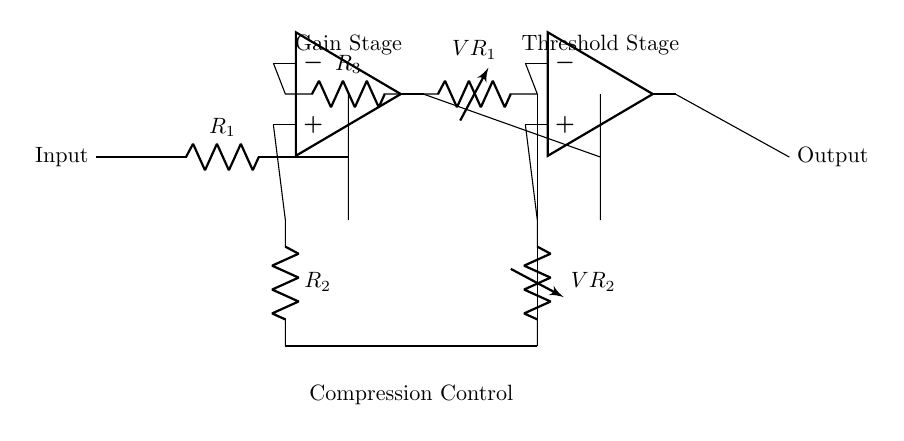What is the role of R1 in this circuit? R1 is a resistor that limits the input current to the first operational amplifier, providing stability to the gain stage.
Answer: Current limiter What is the function of VR1? VR1 is a variable resistor that allows adjustment of the feedback resistance, thereby controlling the gain in the compression stage.
Answer: Gain control How many operational amplifiers are used in the circuit? The circuit uses two operational amplifiers, one for the gain stage and one for the threshold stage.
Answer: Two What does the output node represent? The output node represents the final output of the audio compressor after the input signal has been processed by the two operational amplifiers.
Answer: Processed audio signal What does the term "compression control" refer to in this circuit? Compression control refers to the adjustment capabilities provided by the variable resistors (VR1 and VR2) to manipulate the dynamic range of the input audio signal.
Answer: Dynamic range adjustment What is the relationship between R2 and R3 in the feedback network? R2 and R3 work together to set the gain of the first operational amplifier; their values determine the amount of feedback and hence the amplification.
Answer: Gain setting 